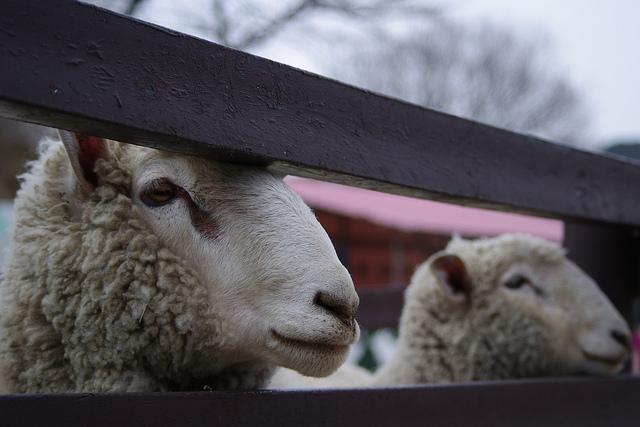What color are the sheep?
Answer briefly. White. Which animals are they?
Short answer required. Sheep. How many sheep are in the picture?
Write a very short answer. 2. 